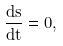Convert formula to latex. <formula><loc_0><loc_0><loc_500><loc_500>\frac { d s } { d t } = 0 ,</formula> 